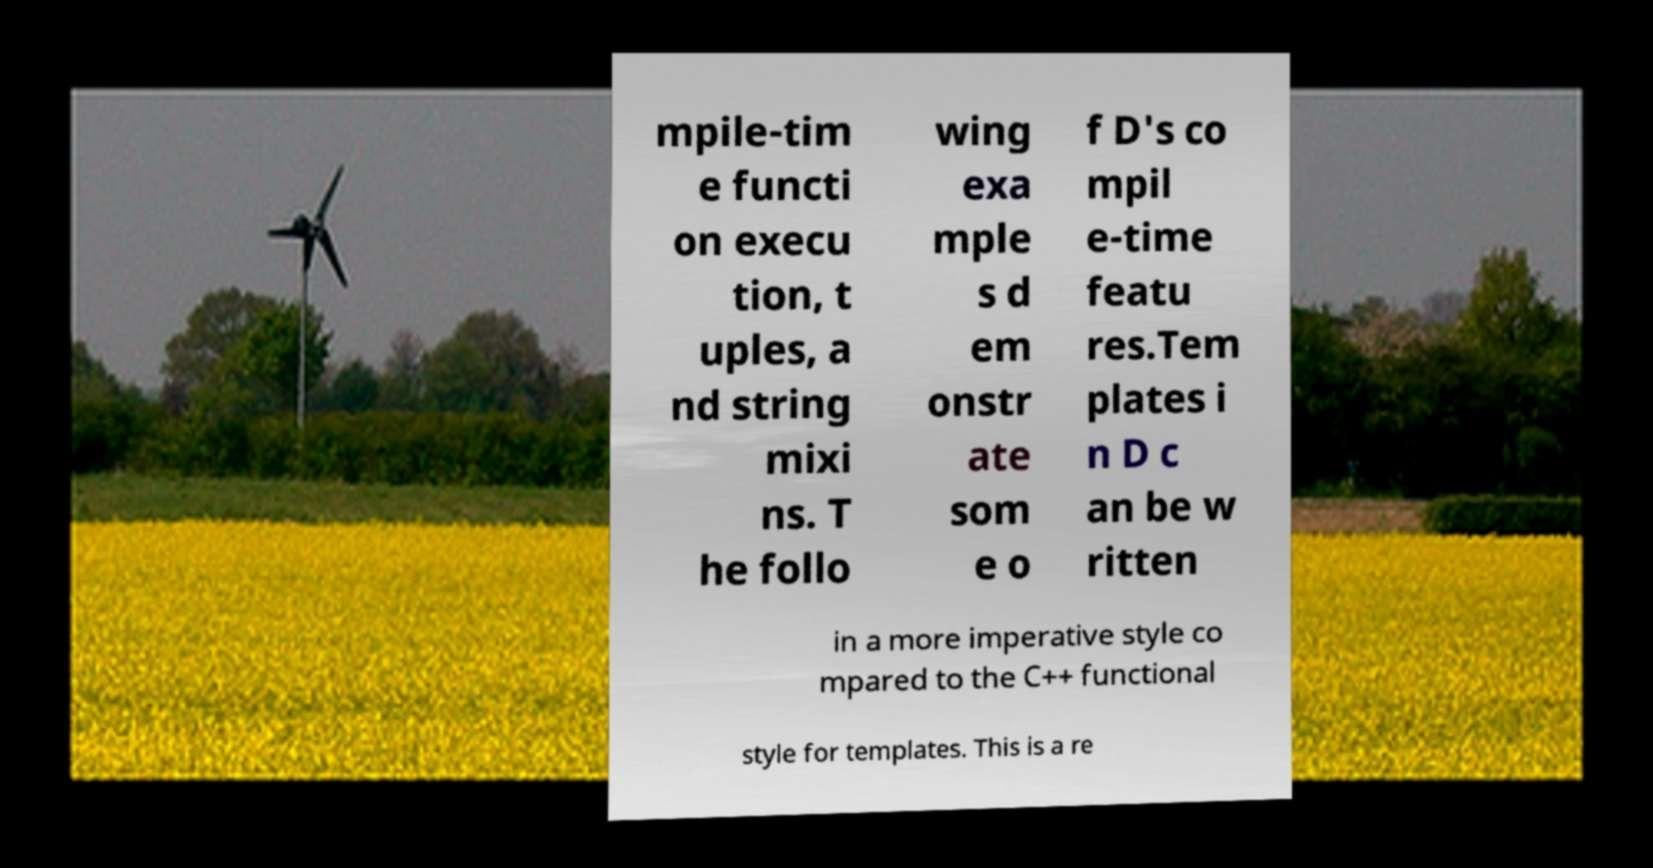There's text embedded in this image that I need extracted. Can you transcribe it verbatim? mpile-tim e functi on execu tion, t uples, a nd string mixi ns. T he follo wing exa mple s d em onstr ate som e o f D's co mpil e-time featu res.Tem plates i n D c an be w ritten in a more imperative style co mpared to the C++ functional style for templates. This is a re 